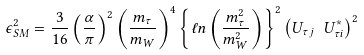<formula> <loc_0><loc_0><loc_500><loc_500>\epsilon _ { S M } ^ { 2 } = \frac { 3 } { 1 6 } \left ( \frac { \alpha } { \pi } \right ) ^ { 2 } \left ( \frac { m _ { \tau } } { m _ { W } } \right ) ^ { 4 } \left \{ \ell n \left ( \frac { m _ { \tau } ^ { 2 } } { m _ { W } ^ { 2 } } \right ) \right \} ^ { 2 } \left ( U _ { \tau j } \ U ^ { * } _ { \tau i } \right ) ^ { 2 }</formula> 